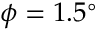<formula> <loc_0><loc_0><loc_500><loc_500>\phi = 1 . 5 ^ { \circ }</formula> 